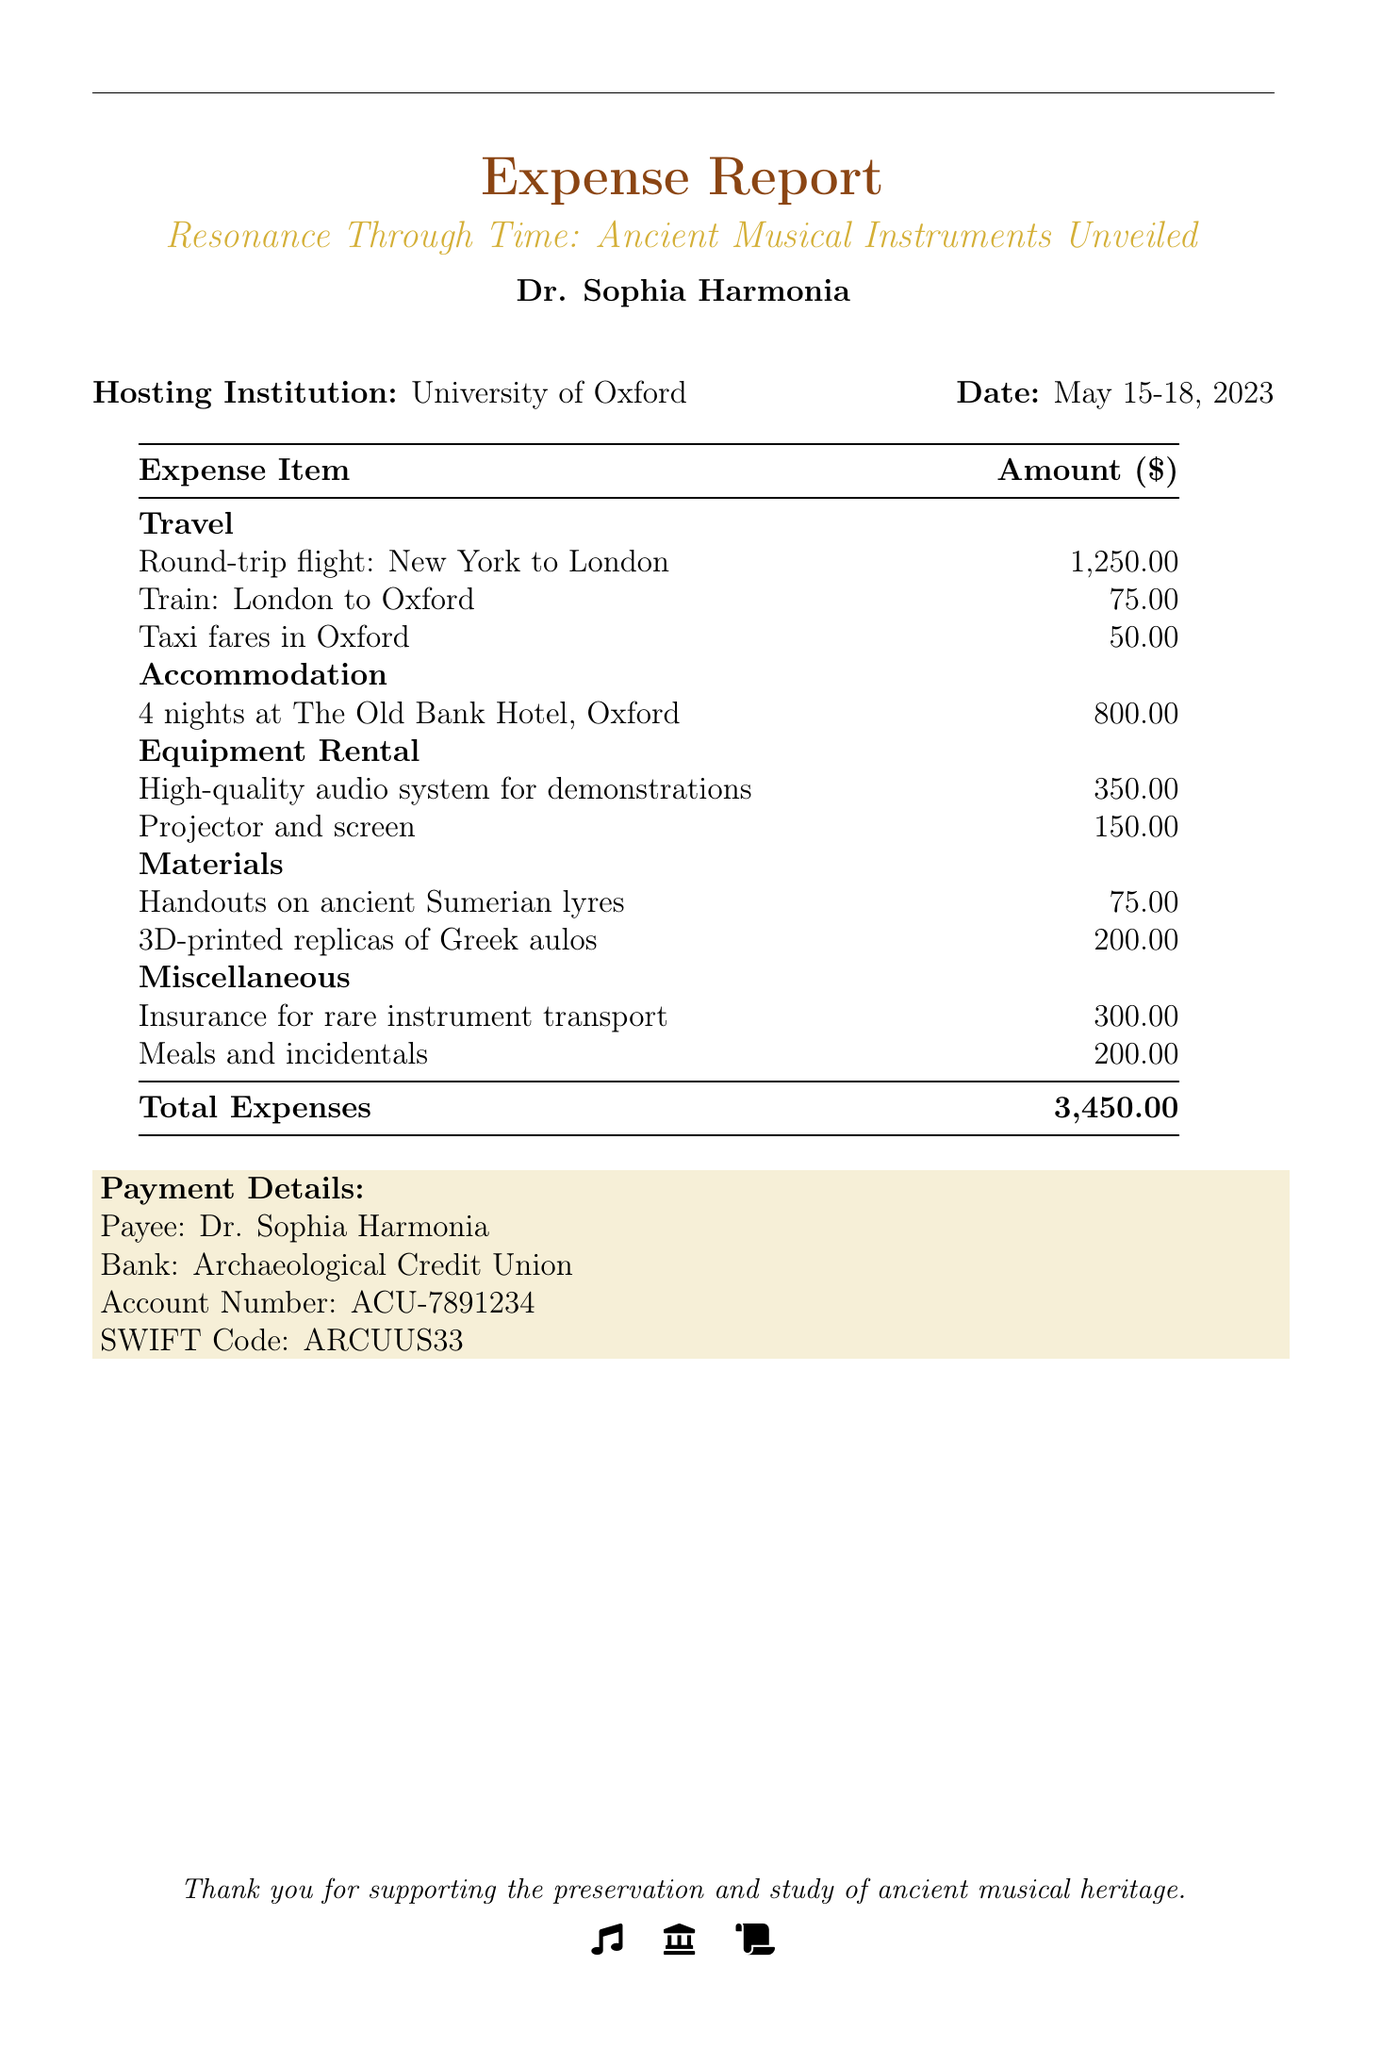what is the total amount of expenses? The total amount of expenses is specified in the document and is calculated from the sum of all expense items listed.
Answer: 3,450.00 who is the payee for the expenses? The payee is mentioned under the payment details section of the document.
Answer: Dr. Sophia Harmonia what is the date of the lecture series? The date is provided in the top section of the document and indicates when the event took place.
Answer: May 15-18, 2023 how much was spent on meals and incidentals? This amount is listed under the miscellaneous expenses section in the table.
Answer: 200.00 where was the accommodation during the event? The accommodation details are noted in the expense report section, specifying the hotel used.
Answer: The Old Bank Hotel, Oxford how much was allocated for equipment rental? The total amount for equipment rental is derived from the sum of the specified items under that category.
Answer: 500.00 what type of bank is mentioned for payment? The type of bank is specified in the payment details section of the document.
Answer: Archaeological Credit Union how many nights were spent in accommodation? The number of nights is explicitly stated next to the accommodation expense item in the document.
Answer: 4 nights 